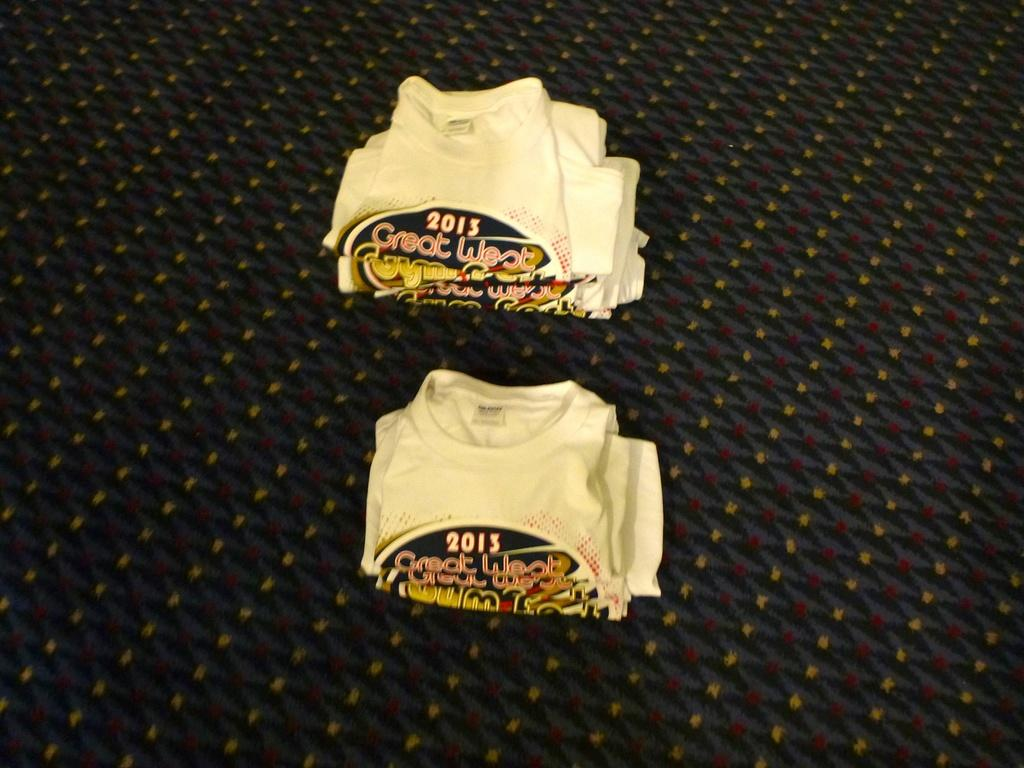<image>
Write a terse but informative summary of the picture. the word 2013 is on the shirt on the ground 